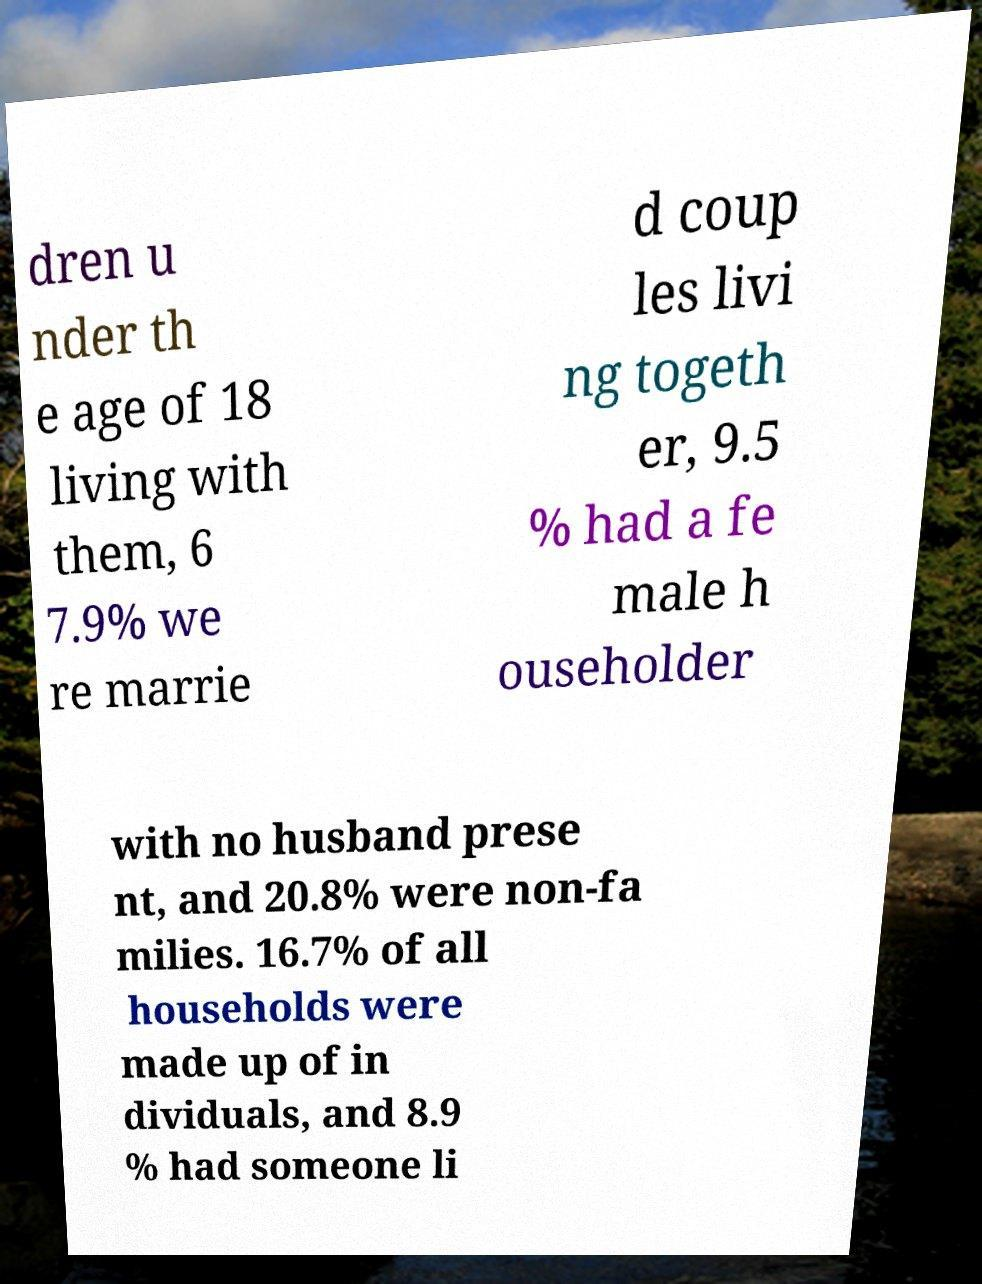I need the written content from this picture converted into text. Can you do that? dren u nder th e age of 18 living with them, 6 7.9% we re marrie d coup les livi ng togeth er, 9.5 % had a fe male h ouseholder with no husband prese nt, and 20.8% were non-fa milies. 16.7% of all households were made up of in dividuals, and 8.9 % had someone li 